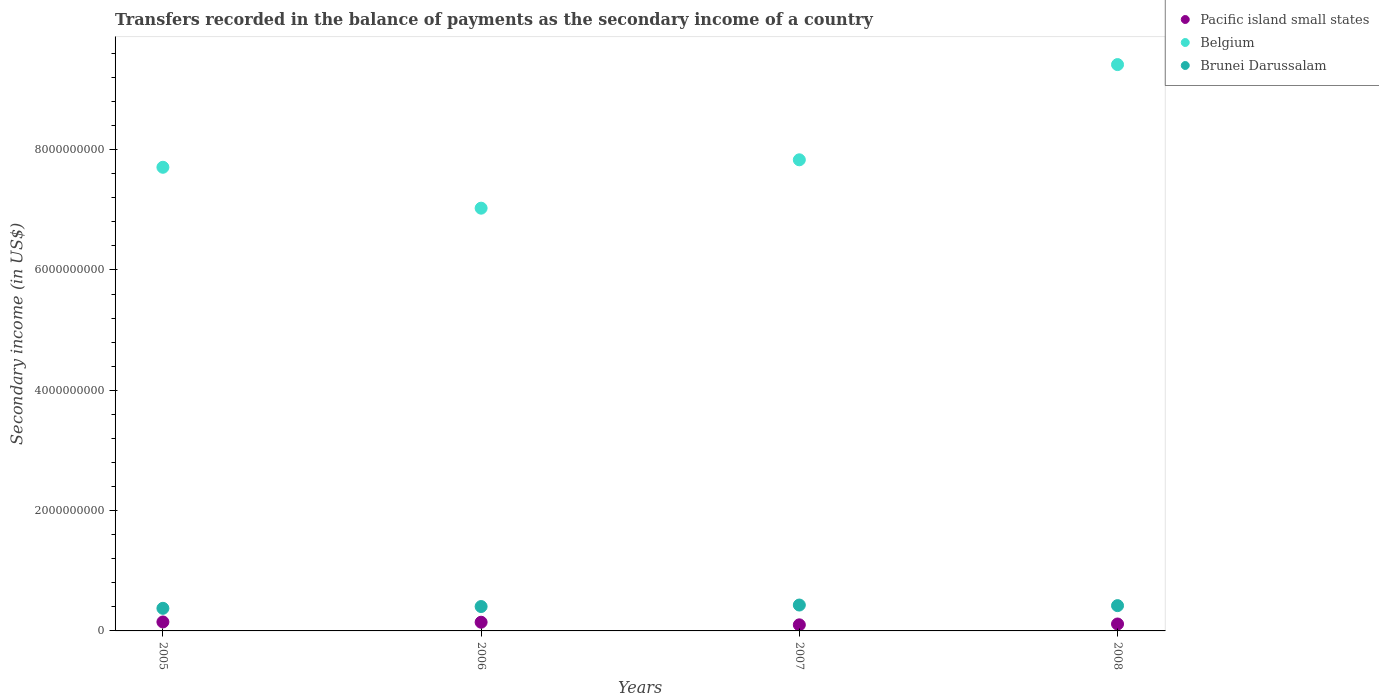How many different coloured dotlines are there?
Make the answer very short. 3. Is the number of dotlines equal to the number of legend labels?
Provide a short and direct response. Yes. What is the secondary income of in Pacific island small states in 2008?
Your response must be concise. 1.15e+08. Across all years, what is the maximum secondary income of in Belgium?
Offer a very short reply. 9.41e+09. Across all years, what is the minimum secondary income of in Brunei Darussalam?
Provide a short and direct response. 3.76e+08. What is the total secondary income of in Brunei Darussalam in the graph?
Keep it short and to the point. 1.63e+09. What is the difference between the secondary income of in Belgium in 2006 and that in 2007?
Your response must be concise. -8.04e+08. What is the difference between the secondary income of in Brunei Darussalam in 2006 and the secondary income of in Belgium in 2007?
Offer a very short reply. -7.43e+09. What is the average secondary income of in Belgium per year?
Make the answer very short. 8.00e+09. In the year 2008, what is the difference between the secondary income of in Belgium and secondary income of in Pacific island small states?
Keep it short and to the point. 9.30e+09. What is the ratio of the secondary income of in Belgium in 2005 to that in 2006?
Give a very brief answer. 1.1. Is the secondary income of in Pacific island small states in 2005 less than that in 2008?
Ensure brevity in your answer.  No. Is the difference between the secondary income of in Belgium in 2006 and 2008 greater than the difference between the secondary income of in Pacific island small states in 2006 and 2008?
Keep it short and to the point. No. What is the difference between the highest and the second highest secondary income of in Brunei Darussalam?
Offer a very short reply. 9.93e+06. What is the difference between the highest and the lowest secondary income of in Brunei Darussalam?
Your response must be concise. 5.47e+07. Is the sum of the secondary income of in Pacific island small states in 2005 and 2007 greater than the maximum secondary income of in Belgium across all years?
Provide a short and direct response. No. Is the secondary income of in Brunei Darussalam strictly greater than the secondary income of in Belgium over the years?
Your answer should be compact. No. How many dotlines are there?
Provide a short and direct response. 3. How many years are there in the graph?
Offer a terse response. 4. Does the graph contain grids?
Provide a short and direct response. No. How many legend labels are there?
Offer a terse response. 3. What is the title of the graph?
Your response must be concise. Transfers recorded in the balance of payments as the secondary income of a country. What is the label or title of the Y-axis?
Make the answer very short. Secondary income (in US$). What is the Secondary income (in US$) in Pacific island small states in 2005?
Offer a very short reply. 1.49e+08. What is the Secondary income (in US$) in Belgium in 2005?
Ensure brevity in your answer.  7.71e+09. What is the Secondary income (in US$) in Brunei Darussalam in 2005?
Ensure brevity in your answer.  3.76e+08. What is the Secondary income (in US$) in Pacific island small states in 2006?
Ensure brevity in your answer.  1.44e+08. What is the Secondary income (in US$) of Belgium in 2006?
Make the answer very short. 7.03e+09. What is the Secondary income (in US$) of Brunei Darussalam in 2006?
Your answer should be compact. 4.05e+08. What is the Secondary income (in US$) of Pacific island small states in 2007?
Provide a succinct answer. 1.01e+08. What is the Secondary income (in US$) of Belgium in 2007?
Ensure brevity in your answer.  7.83e+09. What is the Secondary income (in US$) in Brunei Darussalam in 2007?
Offer a terse response. 4.30e+08. What is the Secondary income (in US$) in Pacific island small states in 2008?
Keep it short and to the point. 1.15e+08. What is the Secondary income (in US$) in Belgium in 2008?
Provide a short and direct response. 9.41e+09. What is the Secondary income (in US$) of Brunei Darussalam in 2008?
Your answer should be very brief. 4.20e+08. Across all years, what is the maximum Secondary income (in US$) in Pacific island small states?
Your answer should be very brief. 1.49e+08. Across all years, what is the maximum Secondary income (in US$) in Belgium?
Ensure brevity in your answer.  9.41e+09. Across all years, what is the maximum Secondary income (in US$) of Brunei Darussalam?
Keep it short and to the point. 4.30e+08. Across all years, what is the minimum Secondary income (in US$) in Pacific island small states?
Offer a very short reply. 1.01e+08. Across all years, what is the minimum Secondary income (in US$) of Belgium?
Your answer should be compact. 7.03e+09. Across all years, what is the minimum Secondary income (in US$) in Brunei Darussalam?
Ensure brevity in your answer.  3.76e+08. What is the total Secondary income (in US$) in Pacific island small states in the graph?
Offer a terse response. 5.10e+08. What is the total Secondary income (in US$) in Belgium in the graph?
Give a very brief answer. 3.20e+1. What is the total Secondary income (in US$) in Brunei Darussalam in the graph?
Ensure brevity in your answer.  1.63e+09. What is the difference between the Secondary income (in US$) in Pacific island small states in 2005 and that in 2006?
Your response must be concise. 4.54e+06. What is the difference between the Secondary income (in US$) of Belgium in 2005 and that in 2006?
Provide a succinct answer. 6.80e+08. What is the difference between the Secondary income (in US$) in Brunei Darussalam in 2005 and that in 2006?
Provide a short and direct response. -2.99e+07. What is the difference between the Secondary income (in US$) of Pacific island small states in 2005 and that in 2007?
Offer a very short reply. 4.78e+07. What is the difference between the Secondary income (in US$) of Belgium in 2005 and that in 2007?
Your answer should be compact. -1.24e+08. What is the difference between the Secondary income (in US$) in Brunei Darussalam in 2005 and that in 2007?
Offer a very short reply. -5.47e+07. What is the difference between the Secondary income (in US$) of Pacific island small states in 2005 and that in 2008?
Your answer should be very brief. 3.38e+07. What is the difference between the Secondary income (in US$) in Belgium in 2005 and that in 2008?
Make the answer very short. -1.71e+09. What is the difference between the Secondary income (in US$) in Brunei Darussalam in 2005 and that in 2008?
Give a very brief answer. -4.48e+07. What is the difference between the Secondary income (in US$) of Pacific island small states in 2006 and that in 2007?
Your response must be concise. 4.33e+07. What is the difference between the Secondary income (in US$) in Belgium in 2006 and that in 2007?
Your answer should be compact. -8.04e+08. What is the difference between the Secondary income (in US$) of Brunei Darussalam in 2006 and that in 2007?
Keep it short and to the point. -2.48e+07. What is the difference between the Secondary income (in US$) in Pacific island small states in 2006 and that in 2008?
Your answer should be very brief. 2.93e+07. What is the difference between the Secondary income (in US$) of Belgium in 2006 and that in 2008?
Provide a short and direct response. -2.39e+09. What is the difference between the Secondary income (in US$) of Brunei Darussalam in 2006 and that in 2008?
Your answer should be very brief. -1.49e+07. What is the difference between the Secondary income (in US$) of Pacific island small states in 2007 and that in 2008?
Provide a succinct answer. -1.40e+07. What is the difference between the Secondary income (in US$) in Belgium in 2007 and that in 2008?
Your answer should be very brief. -1.58e+09. What is the difference between the Secondary income (in US$) in Brunei Darussalam in 2007 and that in 2008?
Your answer should be very brief. 9.93e+06. What is the difference between the Secondary income (in US$) of Pacific island small states in 2005 and the Secondary income (in US$) of Belgium in 2006?
Offer a very short reply. -6.88e+09. What is the difference between the Secondary income (in US$) of Pacific island small states in 2005 and the Secondary income (in US$) of Brunei Darussalam in 2006?
Keep it short and to the point. -2.56e+08. What is the difference between the Secondary income (in US$) of Belgium in 2005 and the Secondary income (in US$) of Brunei Darussalam in 2006?
Your response must be concise. 7.30e+09. What is the difference between the Secondary income (in US$) in Pacific island small states in 2005 and the Secondary income (in US$) in Belgium in 2007?
Your answer should be compact. -7.68e+09. What is the difference between the Secondary income (in US$) in Pacific island small states in 2005 and the Secondary income (in US$) in Brunei Darussalam in 2007?
Your answer should be very brief. -2.81e+08. What is the difference between the Secondary income (in US$) in Belgium in 2005 and the Secondary income (in US$) in Brunei Darussalam in 2007?
Make the answer very short. 7.28e+09. What is the difference between the Secondary income (in US$) of Pacific island small states in 2005 and the Secondary income (in US$) of Belgium in 2008?
Your answer should be compact. -9.27e+09. What is the difference between the Secondary income (in US$) of Pacific island small states in 2005 and the Secondary income (in US$) of Brunei Darussalam in 2008?
Make the answer very short. -2.71e+08. What is the difference between the Secondary income (in US$) in Belgium in 2005 and the Secondary income (in US$) in Brunei Darussalam in 2008?
Your answer should be very brief. 7.29e+09. What is the difference between the Secondary income (in US$) of Pacific island small states in 2006 and the Secondary income (in US$) of Belgium in 2007?
Offer a terse response. -7.69e+09. What is the difference between the Secondary income (in US$) in Pacific island small states in 2006 and the Secondary income (in US$) in Brunei Darussalam in 2007?
Your answer should be very brief. -2.86e+08. What is the difference between the Secondary income (in US$) in Belgium in 2006 and the Secondary income (in US$) in Brunei Darussalam in 2007?
Provide a short and direct response. 6.60e+09. What is the difference between the Secondary income (in US$) in Pacific island small states in 2006 and the Secondary income (in US$) in Belgium in 2008?
Keep it short and to the point. -9.27e+09. What is the difference between the Secondary income (in US$) in Pacific island small states in 2006 and the Secondary income (in US$) in Brunei Darussalam in 2008?
Your answer should be compact. -2.76e+08. What is the difference between the Secondary income (in US$) of Belgium in 2006 and the Secondary income (in US$) of Brunei Darussalam in 2008?
Provide a succinct answer. 6.61e+09. What is the difference between the Secondary income (in US$) in Pacific island small states in 2007 and the Secondary income (in US$) in Belgium in 2008?
Provide a succinct answer. -9.31e+09. What is the difference between the Secondary income (in US$) of Pacific island small states in 2007 and the Secondary income (in US$) of Brunei Darussalam in 2008?
Offer a very short reply. -3.19e+08. What is the difference between the Secondary income (in US$) in Belgium in 2007 and the Secondary income (in US$) in Brunei Darussalam in 2008?
Make the answer very short. 7.41e+09. What is the average Secondary income (in US$) of Pacific island small states per year?
Offer a very short reply. 1.27e+08. What is the average Secondary income (in US$) in Belgium per year?
Ensure brevity in your answer.  8.00e+09. What is the average Secondary income (in US$) in Brunei Darussalam per year?
Provide a succinct answer. 4.08e+08. In the year 2005, what is the difference between the Secondary income (in US$) of Pacific island small states and Secondary income (in US$) of Belgium?
Ensure brevity in your answer.  -7.56e+09. In the year 2005, what is the difference between the Secondary income (in US$) of Pacific island small states and Secondary income (in US$) of Brunei Darussalam?
Give a very brief answer. -2.27e+08. In the year 2005, what is the difference between the Secondary income (in US$) in Belgium and Secondary income (in US$) in Brunei Darussalam?
Provide a short and direct response. 7.33e+09. In the year 2006, what is the difference between the Secondary income (in US$) in Pacific island small states and Secondary income (in US$) in Belgium?
Provide a succinct answer. -6.88e+09. In the year 2006, what is the difference between the Secondary income (in US$) in Pacific island small states and Secondary income (in US$) in Brunei Darussalam?
Offer a very short reply. -2.61e+08. In the year 2006, what is the difference between the Secondary income (in US$) of Belgium and Secondary income (in US$) of Brunei Darussalam?
Your answer should be very brief. 6.62e+09. In the year 2007, what is the difference between the Secondary income (in US$) in Pacific island small states and Secondary income (in US$) in Belgium?
Provide a succinct answer. -7.73e+09. In the year 2007, what is the difference between the Secondary income (in US$) in Pacific island small states and Secondary income (in US$) in Brunei Darussalam?
Your answer should be very brief. -3.29e+08. In the year 2007, what is the difference between the Secondary income (in US$) of Belgium and Secondary income (in US$) of Brunei Darussalam?
Give a very brief answer. 7.40e+09. In the year 2008, what is the difference between the Secondary income (in US$) of Pacific island small states and Secondary income (in US$) of Belgium?
Your response must be concise. -9.30e+09. In the year 2008, what is the difference between the Secondary income (in US$) of Pacific island small states and Secondary income (in US$) of Brunei Darussalam?
Make the answer very short. -3.05e+08. In the year 2008, what is the difference between the Secondary income (in US$) in Belgium and Secondary income (in US$) in Brunei Darussalam?
Your response must be concise. 8.99e+09. What is the ratio of the Secondary income (in US$) in Pacific island small states in 2005 to that in 2006?
Ensure brevity in your answer.  1.03. What is the ratio of the Secondary income (in US$) of Belgium in 2005 to that in 2006?
Give a very brief answer. 1.1. What is the ratio of the Secondary income (in US$) of Brunei Darussalam in 2005 to that in 2006?
Your response must be concise. 0.93. What is the ratio of the Secondary income (in US$) of Pacific island small states in 2005 to that in 2007?
Ensure brevity in your answer.  1.47. What is the ratio of the Secondary income (in US$) in Belgium in 2005 to that in 2007?
Provide a succinct answer. 0.98. What is the ratio of the Secondary income (in US$) in Brunei Darussalam in 2005 to that in 2007?
Offer a terse response. 0.87. What is the ratio of the Secondary income (in US$) in Pacific island small states in 2005 to that in 2008?
Keep it short and to the point. 1.29. What is the ratio of the Secondary income (in US$) in Belgium in 2005 to that in 2008?
Your answer should be very brief. 0.82. What is the ratio of the Secondary income (in US$) in Brunei Darussalam in 2005 to that in 2008?
Provide a short and direct response. 0.89. What is the ratio of the Secondary income (in US$) of Pacific island small states in 2006 to that in 2007?
Make the answer very short. 1.43. What is the ratio of the Secondary income (in US$) of Belgium in 2006 to that in 2007?
Your answer should be compact. 0.9. What is the ratio of the Secondary income (in US$) of Brunei Darussalam in 2006 to that in 2007?
Offer a terse response. 0.94. What is the ratio of the Secondary income (in US$) of Pacific island small states in 2006 to that in 2008?
Keep it short and to the point. 1.25. What is the ratio of the Secondary income (in US$) in Belgium in 2006 to that in 2008?
Ensure brevity in your answer.  0.75. What is the ratio of the Secondary income (in US$) of Brunei Darussalam in 2006 to that in 2008?
Offer a terse response. 0.96. What is the ratio of the Secondary income (in US$) in Pacific island small states in 2007 to that in 2008?
Offer a terse response. 0.88. What is the ratio of the Secondary income (in US$) of Belgium in 2007 to that in 2008?
Provide a short and direct response. 0.83. What is the ratio of the Secondary income (in US$) of Brunei Darussalam in 2007 to that in 2008?
Provide a short and direct response. 1.02. What is the difference between the highest and the second highest Secondary income (in US$) in Pacific island small states?
Your answer should be compact. 4.54e+06. What is the difference between the highest and the second highest Secondary income (in US$) of Belgium?
Ensure brevity in your answer.  1.58e+09. What is the difference between the highest and the second highest Secondary income (in US$) of Brunei Darussalam?
Your answer should be compact. 9.93e+06. What is the difference between the highest and the lowest Secondary income (in US$) in Pacific island small states?
Provide a succinct answer. 4.78e+07. What is the difference between the highest and the lowest Secondary income (in US$) in Belgium?
Your response must be concise. 2.39e+09. What is the difference between the highest and the lowest Secondary income (in US$) in Brunei Darussalam?
Ensure brevity in your answer.  5.47e+07. 